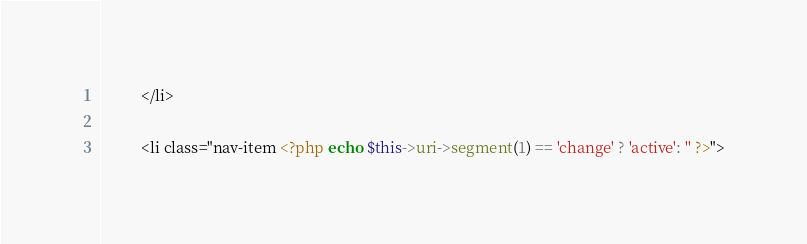<code> <loc_0><loc_0><loc_500><loc_500><_PHP_>          </li>
          
          <li class="nav-item <?php echo $this->uri->segment(1) == 'change' ? 'active': '' ?>"></code> 